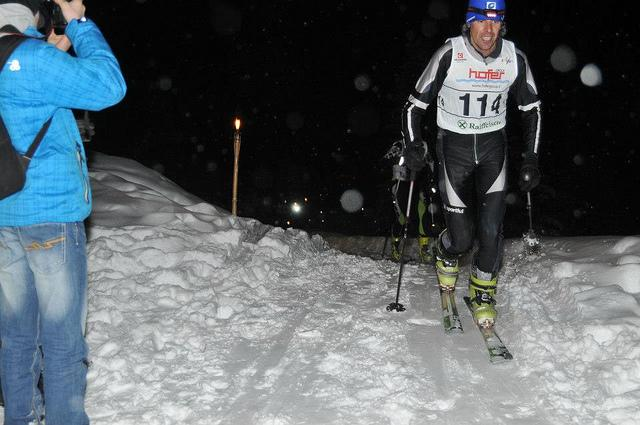What is that light in the distance called?

Choices:
A) lamp
B) post
C) street lamp
D) torch torch 